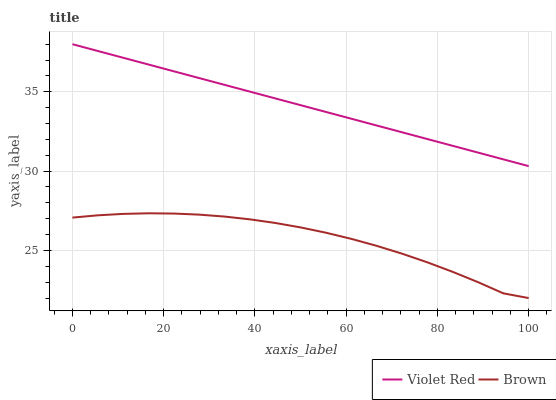Does Brown have the minimum area under the curve?
Answer yes or no. Yes. Does Violet Red have the maximum area under the curve?
Answer yes or no. Yes. Does Violet Red have the minimum area under the curve?
Answer yes or no. No. Is Violet Red the smoothest?
Answer yes or no. Yes. Is Brown the roughest?
Answer yes or no. Yes. Is Violet Red the roughest?
Answer yes or no. No. Does Brown have the lowest value?
Answer yes or no. Yes. Does Violet Red have the lowest value?
Answer yes or no. No. Does Violet Red have the highest value?
Answer yes or no. Yes. Is Brown less than Violet Red?
Answer yes or no. Yes. Is Violet Red greater than Brown?
Answer yes or no. Yes. Does Brown intersect Violet Red?
Answer yes or no. No. 